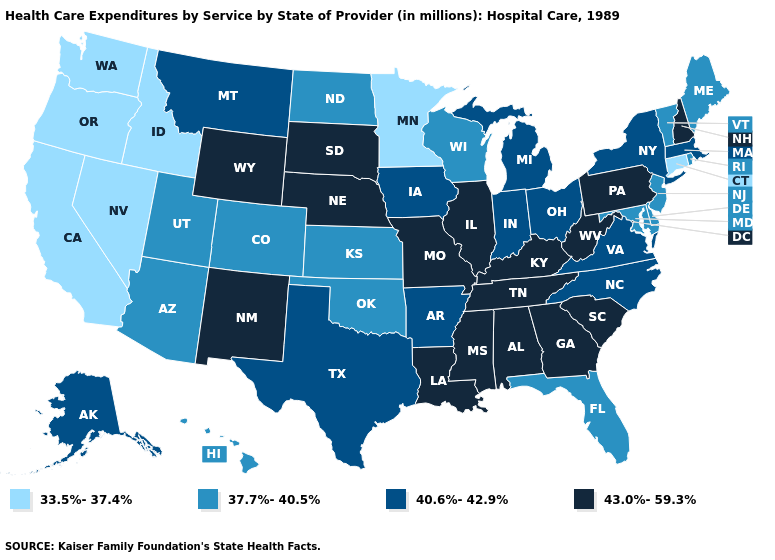What is the lowest value in the South?
Answer briefly. 37.7%-40.5%. Does Michigan have a higher value than Colorado?
Give a very brief answer. Yes. What is the lowest value in the USA?
Give a very brief answer. 33.5%-37.4%. Name the states that have a value in the range 40.6%-42.9%?
Concise answer only. Alaska, Arkansas, Indiana, Iowa, Massachusetts, Michigan, Montana, New York, North Carolina, Ohio, Texas, Virginia. Name the states that have a value in the range 37.7%-40.5%?
Short answer required. Arizona, Colorado, Delaware, Florida, Hawaii, Kansas, Maine, Maryland, New Jersey, North Dakota, Oklahoma, Rhode Island, Utah, Vermont, Wisconsin. What is the highest value in the West ?
Be succinct. 43.0%-59.3%. Which states hav the highest value in the South?
Be succinct. Alabama, Georgia, Kentucky, Louisiana, Mississippi, South Carolina, Tennessee, West Virginia. Which states have the highest value in the USA?
Give a very brief answer. Alabama, Georgia, Illinois, Kentucky, Louisiana, Mississippi, Missouri, Nebraska, New Hampshire, New Mexico, Pennsylvania, South Carolina, South Dakota, Tennessee, West Virginia, Wyoming. Is the legend a continuous bar?
Concise answer only. No. Does the map have missing data?
Answer briefly. No. Which states have the highest value in the USA?
Quick response, please. Alabama, Georgia, Illinois, Kentucky, Louisiana, Mississippi, Missouri, Nebraska, New Hampshire, New Mexico, Pennsylvania, South Carolina, South Dakota, Tennessee, West Virginia, Wyoming. Does Rhode Island have the same value as Delaware?
Short answer required. Yes. Name the states that have a value in the range 37.7%-40.5%?
Concise answer only. Arizona, Colorado, Delaware, Florida, Hawaii, Kansas, Maine, Maryland, New Jersey, North Dakota, Oklahoma, Rhode Island, Utah, Vermont, Wisconsin. Does the first symbol in the legend represent the smallest category?
Answer briefly. Yes. What is the value of New Jersey?
Be succinct. 37.7%-40.5%. 